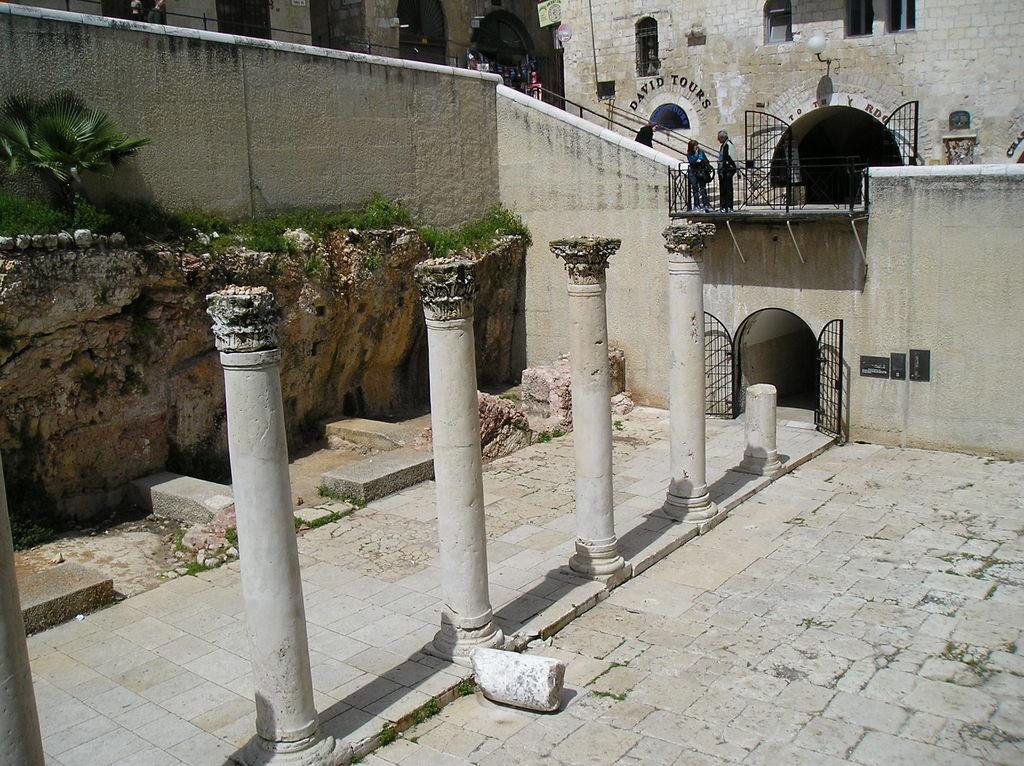What architectural features are present in the image? There are pillars and a building in the image. What is the people's location in relation to the building? The people are standing on the stairs of the building. What is the color of the gate in the image? The gate of the building is black in color. Can you see a plane flying over the building in the image? There is no plane visible in the image. What type of wall is present in the image? There is no wall mentioned or visible in the image; only a building, pillars, and a gate are present. 